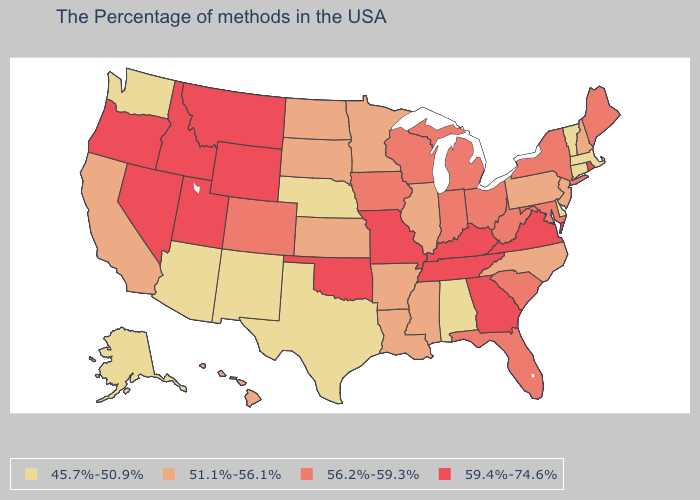Name the states that have a value in the range 59.4%-74.6%?
Concise answer only. Rhode Island, Virginia, Georgia, Kentucky, Tennessee, Missouri, Oklahoma, Wyoming, Utah, Montana, Idaho, Nevada, Oregon. Does Colorado have the lowest value in the West?
Answer briefly. No. What is the value of New Hampshire?
Write a very short answer. 51.1%-56.1%. Which states have the lowest value in the West?
Quick response, please. New Mexico, Arizona, Washington, Alaska. Name the states that have a value in the range 51.1%-56.1%?
Quick response, please. New Hampshire, New Jersey, Pennsylvania, North Carolina, Illinois, Mississippi, Louisiana, Arkansas, Minnesota, Kansas, South Dakota, North Dakota, California, Hawaii. What is the value of Tennessee?
Keep it brief. 59.4%-74.6%. What is the lowest value in the South?
Answer briefly. 45.7%-50.9%. What is the value of Illinois?
Short answer required. 51.1%-56.1%. Does the first symbol in the legend represent the smallest category?
Be succinct. Yes. Does Virginia have the same value as Idaho?
Be succinct. Yes. What is the value of New Hampshire?
Answer briefly. 51.1%-56.1%. Name the states that have a value in the range 45.7%-50.9%?
Write a very short answer. Massachusetts, Vermont, Connecticut, Delaware, Alabama, Nebraska, Texas, New Mexico, Arizona, Washington, Alaska. Does Pennsylvania have a higher value than Ohio?
Quick response, please. No. How many symbols are there in the legend?
Concise answer only. 4. What is the value of Alabama?
Answer briefly. 45.7%-50.9%. 